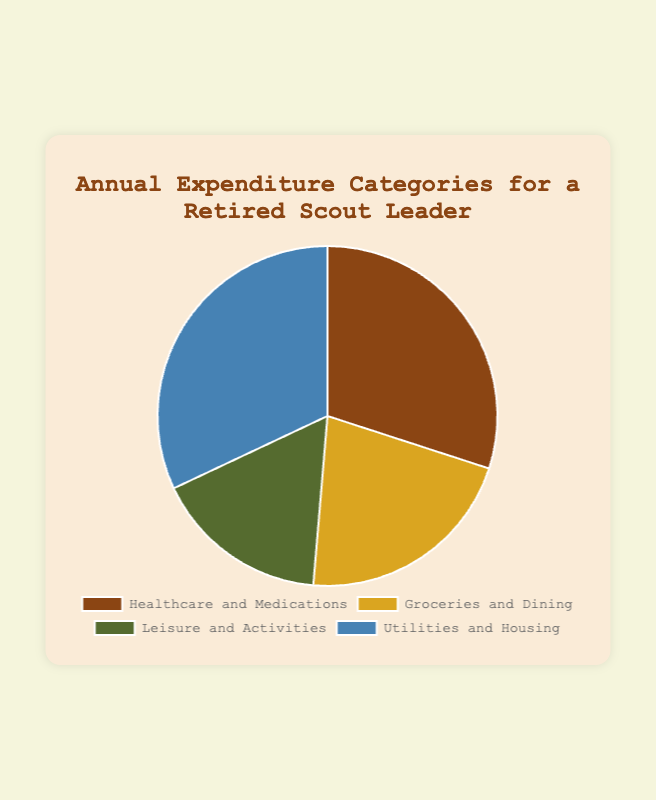What's the largest category in the annual expenditure? The largest category is identified by the largest segment in the pie chart. The 'Utilities and Housing' category is the largest, as it represents $4800.
Answer: Utilities and Housing Which category has the smallest expenditure? The smallest category is identified by the smallest segment in the pie chart. The 'Leisure and Activities' category represents the smallest expenditure of $2500.
Answer: Leisure and Activities What is the total annual expenditure? To find the total annual expenditure, sum up the values from all categories: $4500 (Healthcare and Medications) + $3200 (Groceries and Dining) + $2500 (Leisure and Activities) + $4800 (Utilities and Housing) = $15000.
Answer: $15000 How much more is spent on Utilities and Housing compared to Groceries and Dining? Subtract the amount spent on Groceries and Dining from the amount spent on Utilities and Housing: $4800 (Utilities and Housing) - $3200 (Groceries and Dining) = $1600.
Answer: $1600 Is more money spent on Healthcare and Medications than on Leisure and Activities? Compare the expenditures for Healthcare and Medications ($4500) with Leisure and Activities ($2500). Yes, $4500 is greater than $2500.
Answer: Yes What percentage of the total expenditure is spent on Healthcare and Medications? First, determine the total expenditure: $15000. Then, calculate the percentage: ($4500 / $15000) * 100% = 30%.
Answer: 30% What is the combined expenditure for Groceries and Dining and Leisure and Activities? Add the expenditures for Groceries and Dining ($3200) and Leisure and Activities ($2500): $3200 + $2500 = $5700.
Answer: $5700 What is the average expenditure per category? Calculate the total expenditure: $15000. Divide this total by the number of categories (4): $15000 / 4 = $3750.
Answer: $3750 Which category is represented in blue in the pie chart? Observing the segment colored in blue and matching with the legend provided, the 'Utilities and Housing' category is colored blue.
Answer: Utilities and Housing How much less is spent on Leisure and Activities than on Healthcare and Medications? Subtract the amount spent on Leisure and Activities from the amount spent on Healthcare and Medications: $4500 (Healthcare and Medications) - $2500 (Leisure and Activities) = $2000.
Answer: $2000 